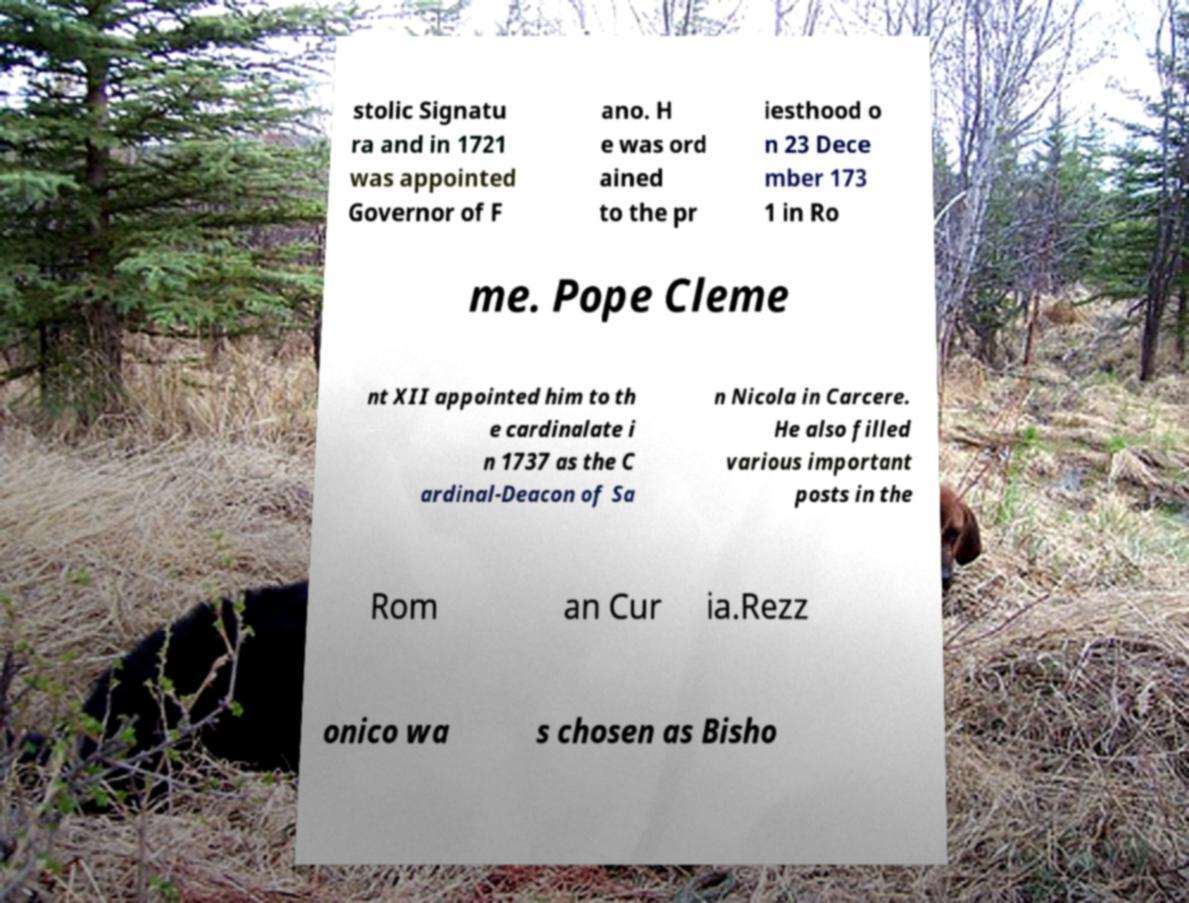Could you extract and type out the text from this image? stolic Signatu ra and in 1721 was appointed Governor of F ano. H e was ord ained to the pr iesthood o n 23 Dece mber 173 1 in Ro me. Pope Cleme nt XII appointed him to th e cardinalate i n 1737 as the C ardinal-Deacon of Sa n Nicola in Carcere. He also filled various important posts in the Rom an Cur ia.Rezz onico wa s chosen as Bisho 